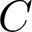<formula> <loc_0><loc_0><loc_500><loc_500>C</formula> 